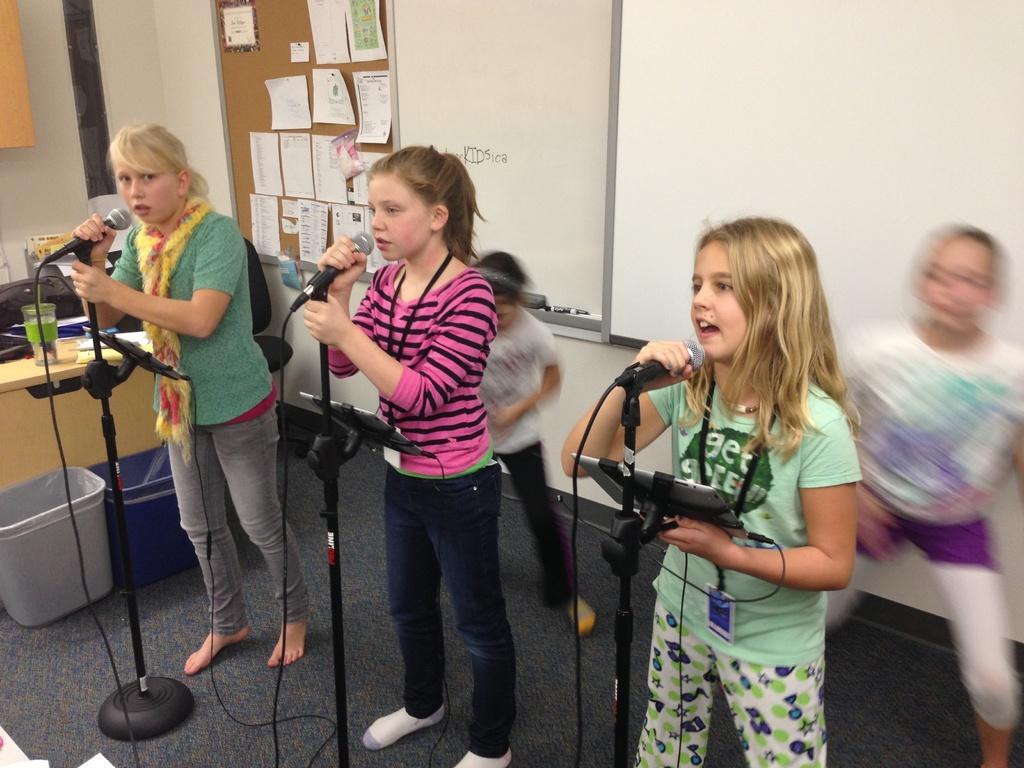Describe this image in one or two sentences. There are three girls, standing in front of a microphones and stands and singing. In the background there are two girls dancing. We can observe a notice board and a white marker board here. 